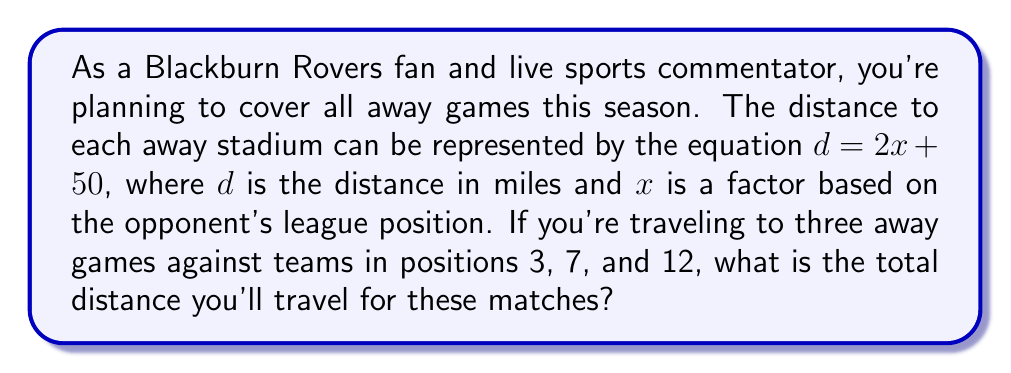Show me your answer to this math problem. Let's approach this step-by-step:

1) We're given the equation $d = 2x + 50$, where:
   $d$ = distance in miles
   $x$ = factor based on opponent's league position

2) We need to calculate the distance for three away games:
   - Team in position 3: $x = 3$
   - Team in position 7: $x = 7$
   - Team in position 12: $x = 12$

3) Let's calculate the distance for each game:

   For position 3: 
   $d_1 = 2(3) + 50 = 6 + 50 = 56$ miles

   For position 7:
   $d_2 = 2(7) + 50 = 14 + 50 = 64$ miles

   For position 12:
   $d_3 = 2(12) + 50 = 24 + 50 = 74$ miles

4) To get the total distance, we sum these individual distances:

   $d_{total} = d_1 + d_2 + d_3 = 56 + 64 + 74 = 194$ miles

Therefore, the total distance traveled for these three away games is 194 miles.
Answer: 194 miles 